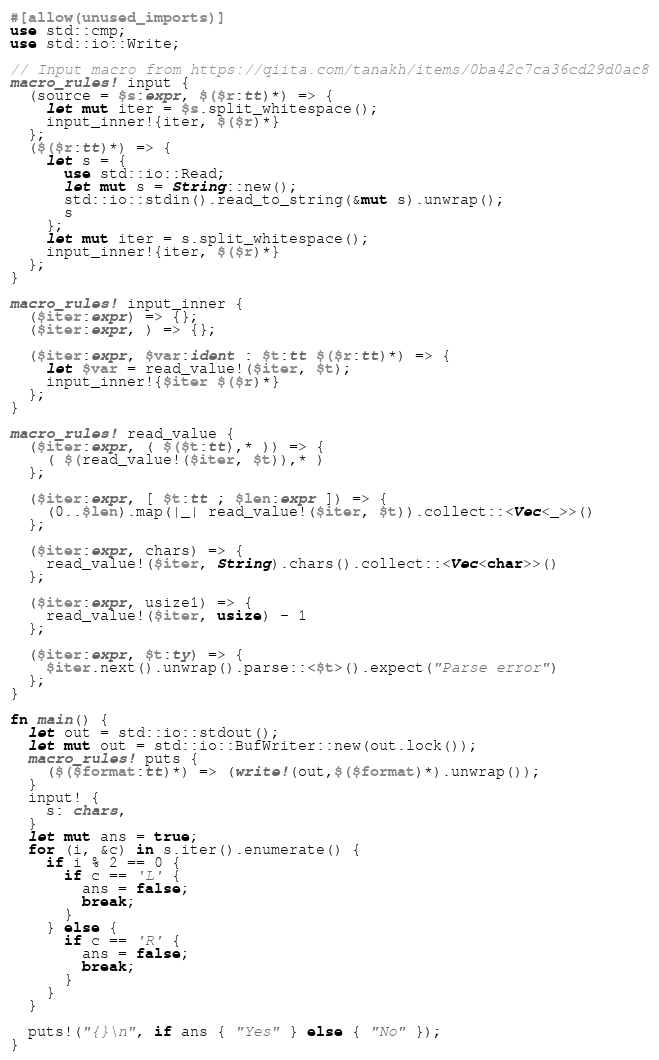<code> <loc_0><loc_0><loc_500><loc_500><_Rust_>#[allow(unused_imports)]
use std::cmp;
use std::io::Write;

// Input macro from https://qiita.com/tanakh/items/0ba42c7ca36cd29d0ac8
macro_rules! input {
  (source = $s:expr, $($r:tt)*) => {
    let mut iter = $s.split_whitespace();
    input_inner!{iter, $($r)*}
  };
  ($($r:tt)*) => {
    let s = {
      use std::io::Read;
      let mut s = String::new();
      std::io::stdin().read_to_string(&mut s).unwrap();
      s
    };
    let mut iter = s.split_whitespace();
    input_inner!{iter, $($r)*}
  };
}

macro_rules! input_inner {
  ($iter:expr) => {};
  ($iter:expr, ) => {};

  ($iter:expr, $var:ident : $t:tt $($r:tt)*) => {
    let $var = read_value!($iter, $t);
    input_inner!{$iter $($r)*}
  };
}

macro_rules! read_value {
  ($iter:expr, ( $($t:tt),* )) => {
    ( $(read_value!($iter, $t)),* )
  };

  ($iter:expr, [ $t:tt ; $len:expr ]) => {
    (0..$len).map(|_| read_value!($iter, $t)).collect::<Vec<_>>()
  };

  ($iter:expr, chars) => {
    read_value!($iter, String).chars().collect::<Vec<char>>()
  };

  ($iter:expr, usize1) => {
    read_value!($iter, usize) - 1
  };

  ($iter:expr, $t:ty) => {
    $iter.next().unwrap().parse::<$t>().expect("Parse error")
  };
}

fn main() {
  let out = std::io::stdout();
  let mut out = std::io::BufWriter::new(out.lock());
  macro_rules! puts {
    ($($format:tt)*) => (write!(out,$($format)*).unwrap());
  }
  input! {
    s: chars,
  }
  let mut ans = true;
  for (i, &c) in s.iter().enumerate() {
    if i % 2 == 0 {
      if c == 'L' {
        ans = false;
        break;
      }
    } else {
      if c == 'R' {
        ans = false;
        break;
      }
    }
  }

  puts!("{}\n", if ans { "Yes" } else { "No" });
}
</code> 